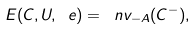<formula> <loc_0><loc_0><loc_500><loc_500>E ( C , U , \ e ) = \ n v _ { - A } ( C ^ { - } ) ,</formula> 